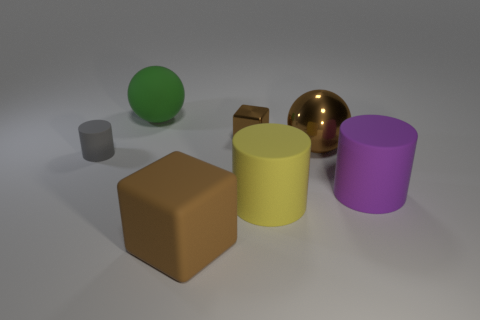Add 2 small cyan rubber balls. How many objects exist? 9 Subtract all spheres. How many objects are left? 5 Subtract 2 brown cubes. How many objects are left? 5 Subtract all large purple rubber objects. Subtract all large yellow objects. How many objects are left? 5 Add 3 metal things. How many metal things are left? 5 Add 6 brown cubes. How many brown cubes exist? 8 